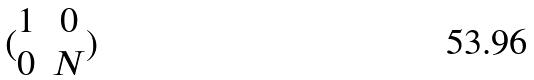Convert formula to latex. <formula><loc_0><loc_0><loc_500><loc_500>( \begin{matrix} 1 & 0 \\ 0 & N \end{matrix} )</formula> 